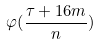Convert formula to latex. <formula><loc_0><loc_0><loc_500><loc_500>\varphi ( \frac { \tau + 1 6 m } { n } )</formula> 